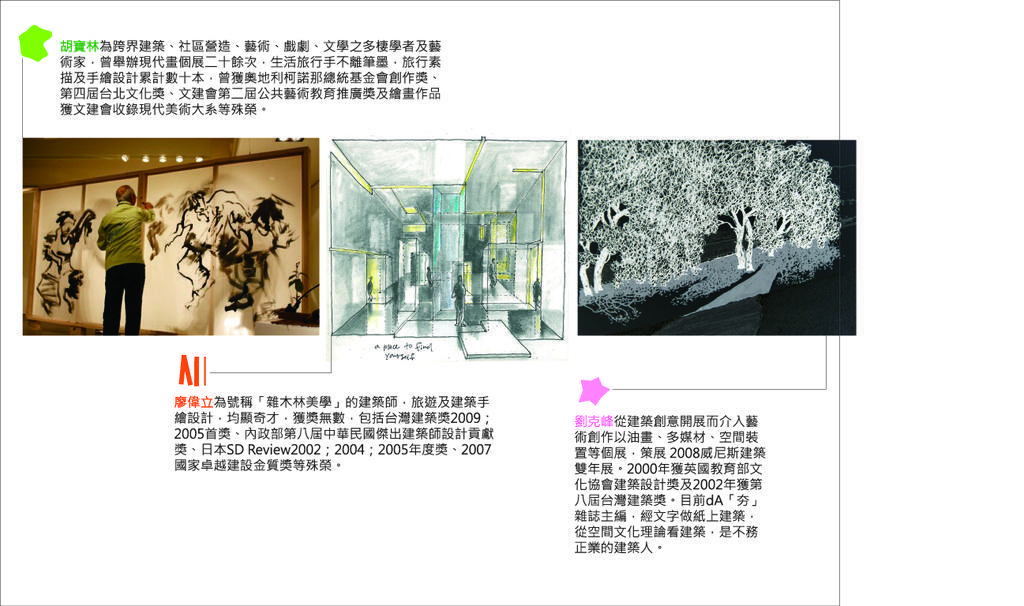How would you summarize this image in a sentence or two? In this image there are three pictures and text. Among them two pictures are edited. We can see a person, trees, board, lights and objects. 